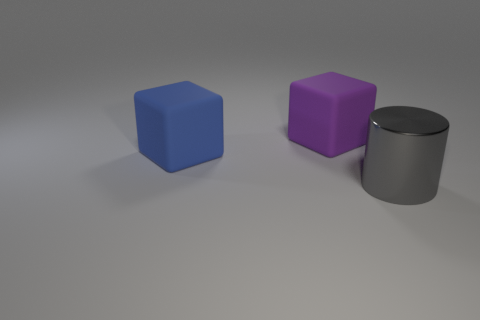There is a matte object that is to the left of the rubber block to the right of the blue rubber object; what is its shape?
Your response must be concise. Cube. Is there anything else that has the same shape as the large blue rubber object?
Your answer should be very brief. Yes. Are there more large metal things that are on the left side of the gray metal object than big brown rubber things?
Offer a terse response. No. What number of big gray cylinders are to the right of the large cube that is on the right side of the big blue matte thing?
Give a very brief answer. 1. What shape is the gray metallic object that is on the right side of the rubber block right of the big matte thing in front of the purple matte thing?
Ensure brevity in your answer.  Cylinder. What is the size of the shiny cylinder?
Provide a short and direct response. Large. Are there any large blue cubes that have the same material as the large purple block?
Your answer should be very brief. Yes. What is the size of the other matte object that is the same shape as the blue thing?
Your answer should be very brief. Large. Are there an equal number of big metal cylinders behind the blue matte block and small rubber spheres?
Make the answer very short. Yes. There is a object behind the blue matte cube; is it the same shape as the big blue object?
Make the answer very short. Yes. 